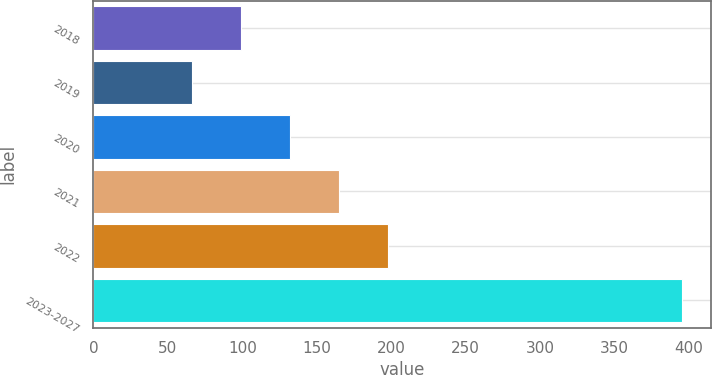Convert chart to OTSL. <chart><loc_0><loc_0><loc_500><loc_500><bar_chart><fcel>2018<fcel>2019<fcel>2020<fcel>2021<fcel>2022<fcel>2023-2027<nl><fcel>98.9<fcel>66<fcel>131.8<fcel>164.7<fcel>197.6<fcel>395<nl></chart> 